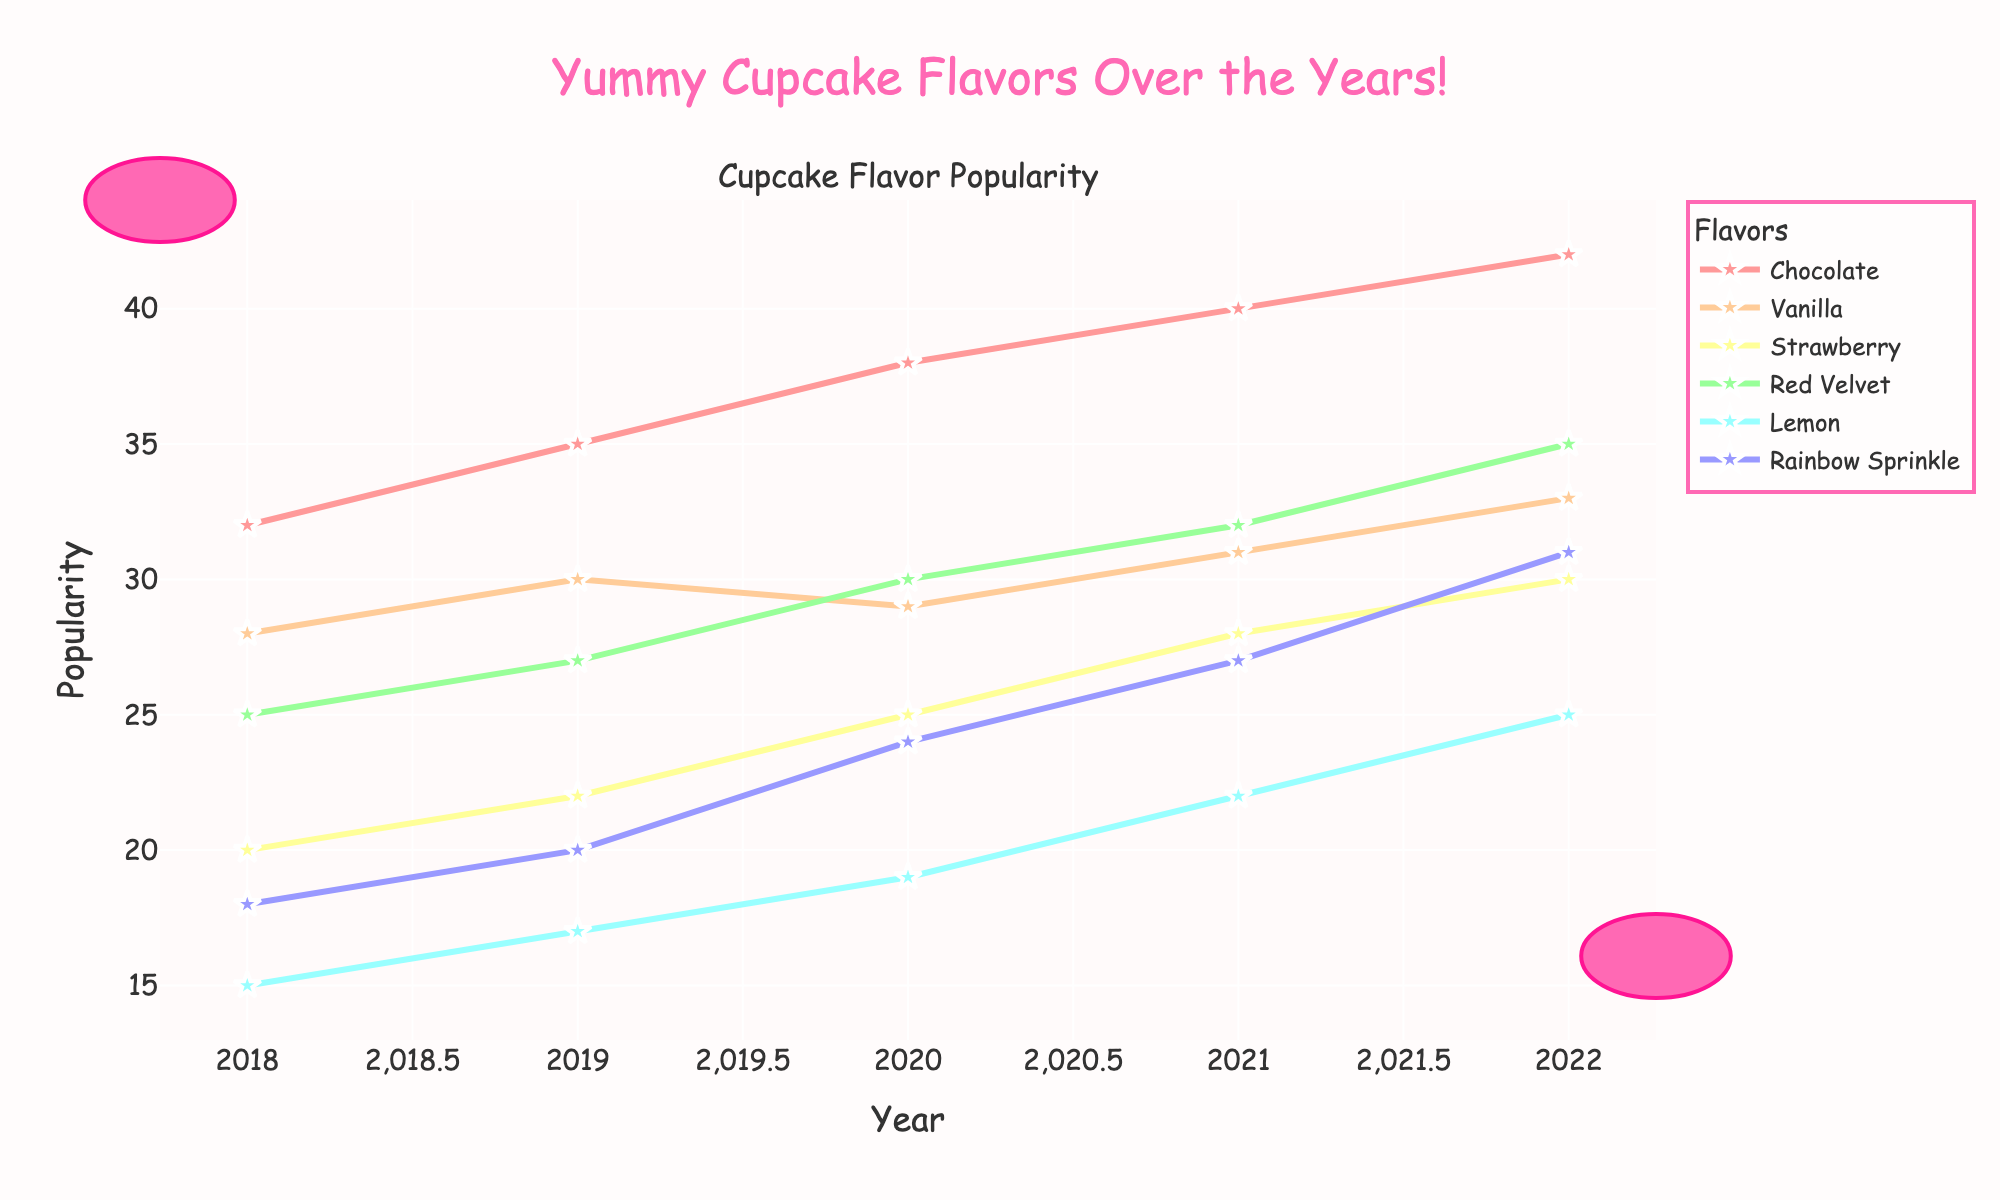Which cupcake flavor was the most popular in 2022? In 2022, Chocolate was the most popular cupcake flavor as it has the highest value on the vertical axis compared to other flavors.
Answer: Chocolate Which cupcake flavor saw the most significant increase in popularity from 2018 to 2022? By looking at the difference between the values in 2018 and 2022 for each flavor, Chocolate increased from 32 to 42, which is the largest increase among all flavors.
Answer: Chocolate In which year did Strawberry flavor surpass the popularity of Vanilla flavor? Examine the trend lines; in 2020, the Strawberry flavor's popularity reached 25, surpassing Vanilla flavor, which was 29.
Answer: 2020 Did Lemon flavor ever surpass Red Velvet flavor in popularity within these five years? No, Lemon's popularity always remains lower than Red Velvet's on the vertical axis throughout these years.
Answer: No What is the average popularity of the Rainbow Sprinkle flavor over the five years? Add the popularity values of Rainbow Sprinkle from 2018 to 2022 (18 + 20 + 24 + 27 + 31) and then divide by 5 to get the average.
Answer: 24 Which year showed the highest total popularity when combining all flavors? Sum the popularity values for each year and compare. 2022 has the highest total with 42 (Chocolate) + 33 (Vanilla) + 30 (Strawberry) + 35 (Red Velvet) + 25 (Lemon) + 31 (Rainbow Sprinkle) = 196.
Answer: 2022 By how much did Vanilla's popularity increase from 2019 to 2022? Vanilla's popularity increased from 30 in 2019 to 33 in 2022. The difference is 33 - 30 = 3.
Answer: 3 Which cupcake flavor had the least increase in popularity from 2018 to 2022? By calculating the difference for each flavor, Lemon increased from 15 to 25, which is the least increase (+10) compared to others.
Answer: Lemon What is the differential popularity between Rainbow Sprinkle and Red Velvet flavors in 2021? For the year 2021, Rainbow Sprinkle had 27 and Red Velvet had 32. The difference is 32 - 27 = 5.
Answer: 5 What was the overall popularity trend for Chocolate flavor from 2018 to 2022? Observing the graph, the popularity for the Chocolate flavor consistently increased year by year from 2018 (32) to 2022 (42).
Answer: Increasing 